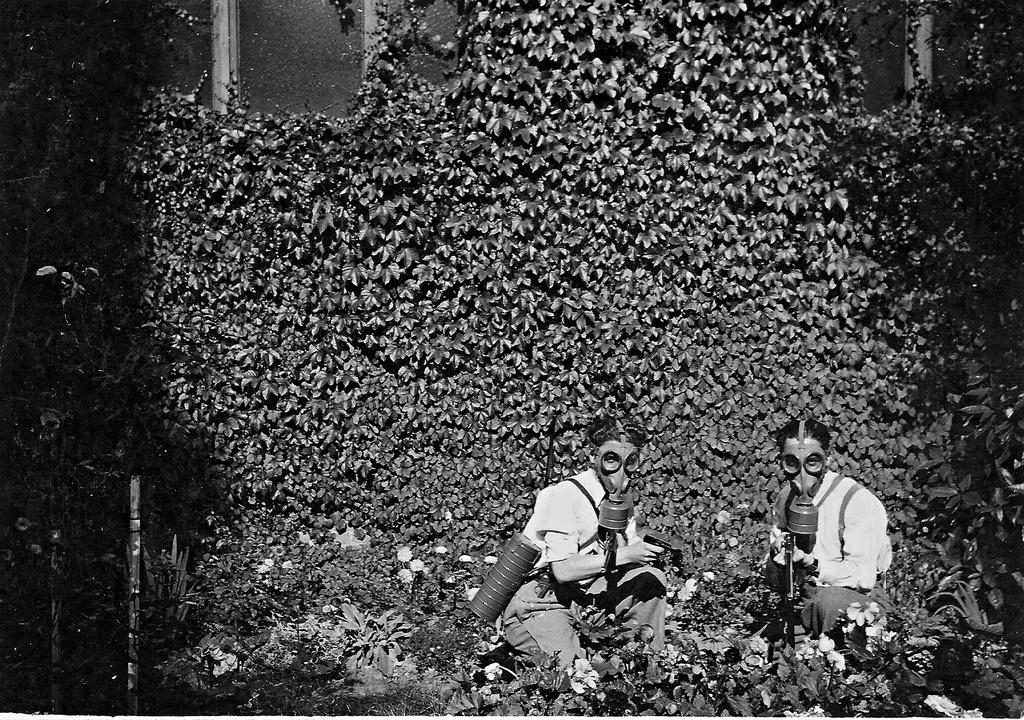How many people are in the image? There are two persons in the image. What are the persons wearing on their faces? The persons are wearing masks. What are the persons holding in their hands? The persons are holding guns. Where are the persons sitting in the image? The persons are sitting on grass land. What type of vegetation is present in the grass land? Plants are present in the grass land. What can be seen on a wall in the background of the image? There is a plant on a wall in the background. What type of clover can be seen growing in the grass land in the image? There is no clover visible in the image; only plants are mentioned. Are the persons in the image on vacation? There is no indication in the image that the persons are on vacation. 